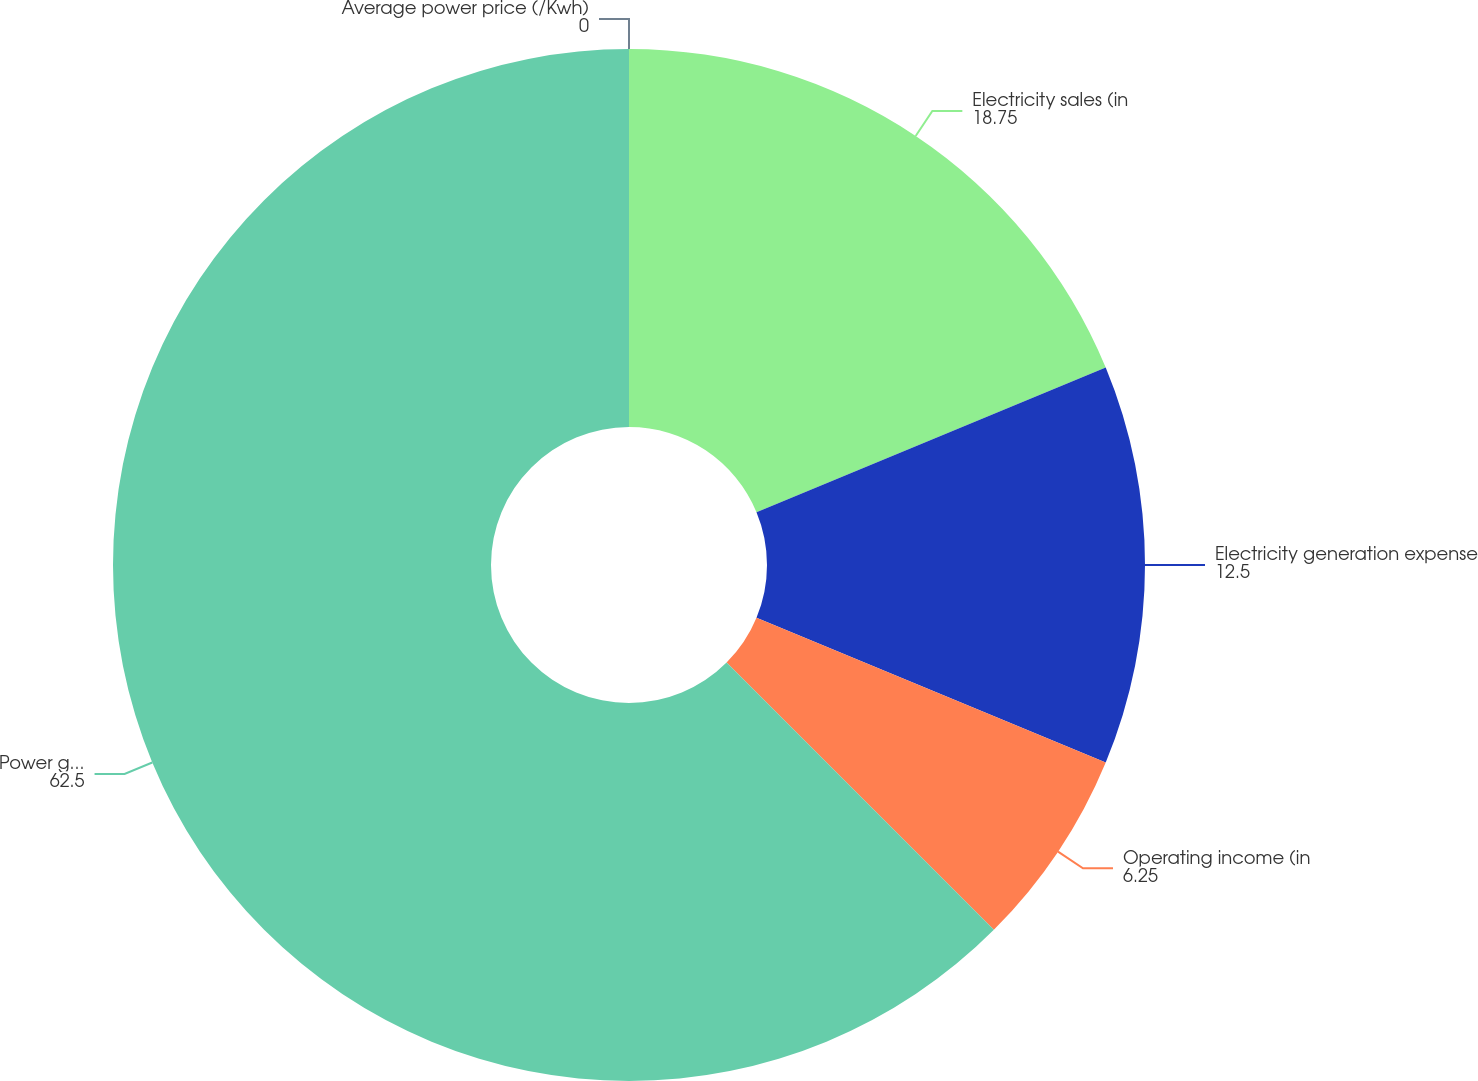<chart> <loc_0><loc_0><loc_500><loc_500><pie_chart><fcel>Electricity sales (in<fcel>Electricity generation expense<fcel>Operating income (in<fcel>Power generation (MW)<fcel>Average power price (/Kwh)<nl><fcel>18.75%<fcel>12.5%<fcel>6.25%<fcel>62.5%<fcel>0.0%<nl></chart> 